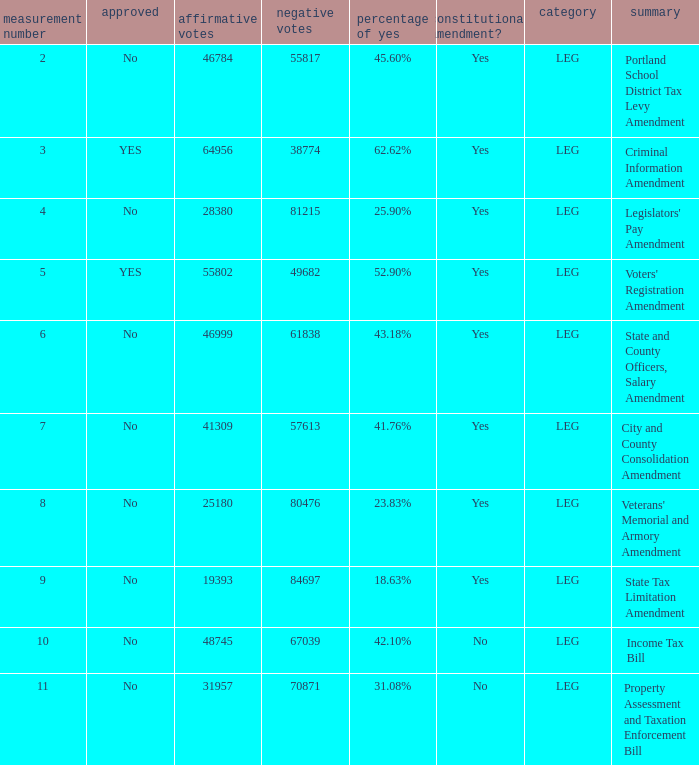HOw many no votes were there when there were 45.60% yes votes 55817.0. 